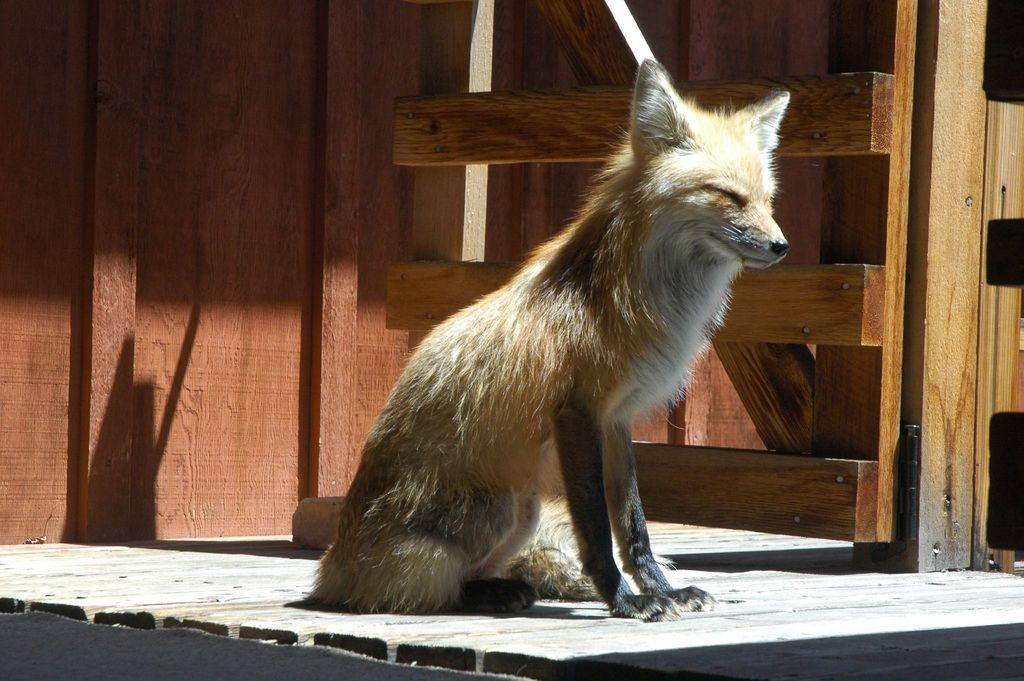How would you summarize this image in a sentence or two? In this picture, we see a fox. Beside that, we see the wooden railing. In the background, we see a wooden wall which is brown in color. At the bottom, we see the wooden floor. 